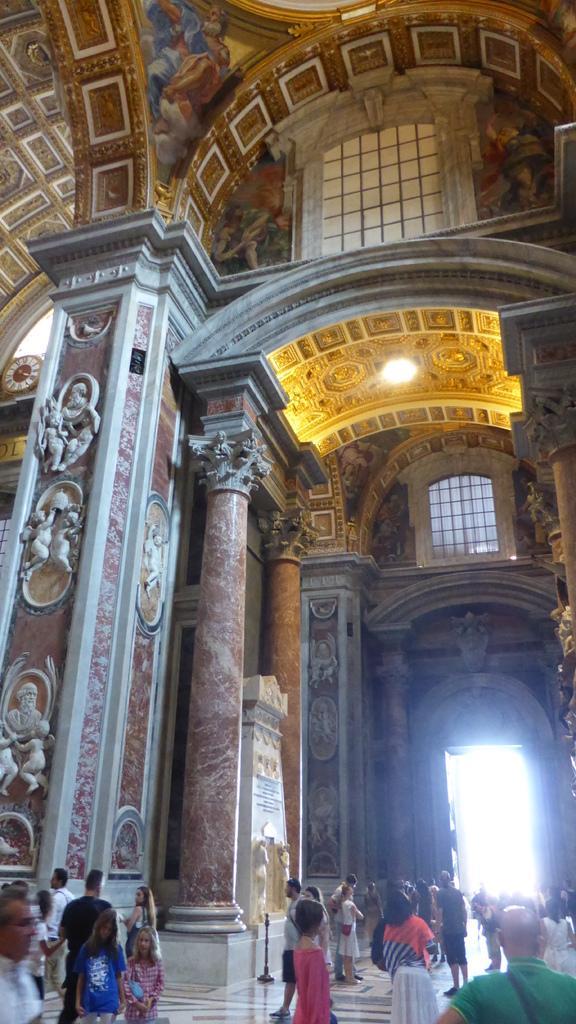Could you give a brief overview of what you see in this image? The image is taken in the hall. At the bottom of the image there are people and a door. At the top we can see a light and windows. 